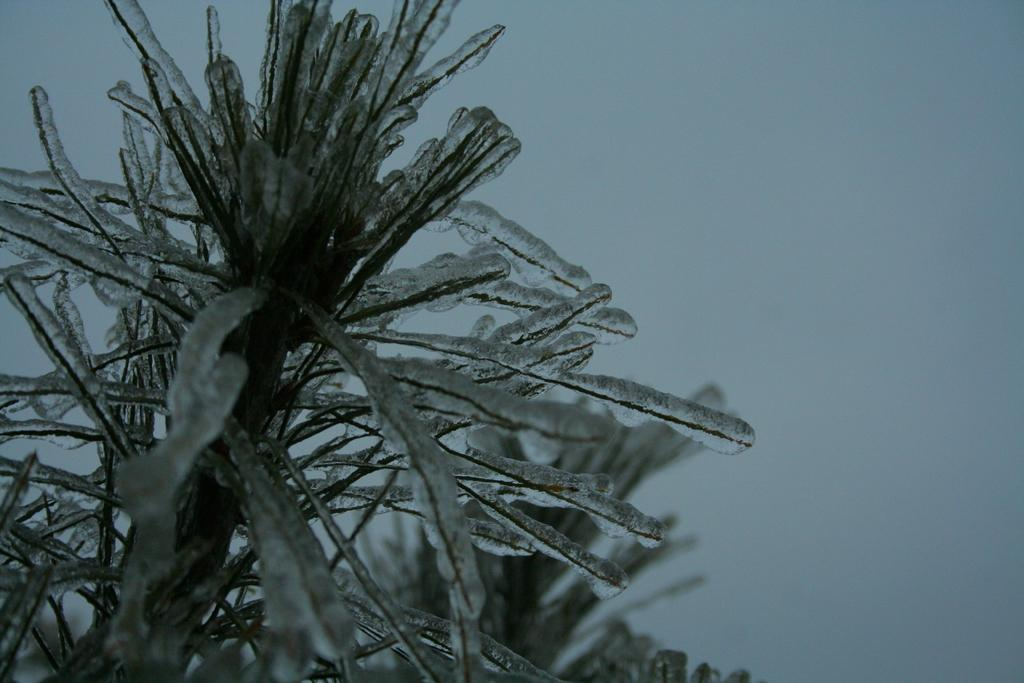What is present in the image? There is a plant in the image. How is the plant affected by the weather or environment? The plant has snow on it. What is the color of the background in the image? The background of the image is white. Can you see the fang of the owl in the image? There is no owl present in the image, so it is not possible to see the fang of an owl. Is the horse wearing a saddle in the image? There is no horse present in the image. 